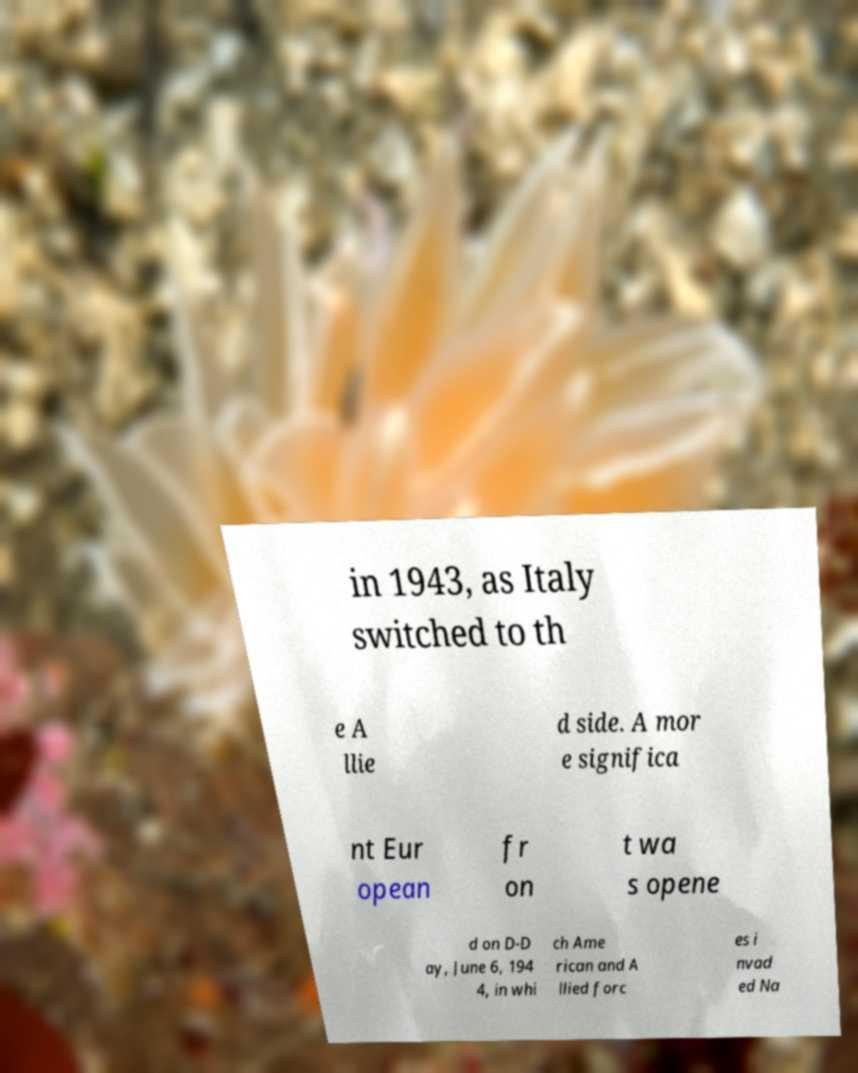Can you read and provide the text displayed in the image?This photo seems to have some interesting text. Can you extract and type it out for me? in 1943, as Italy switched to th e A llie d side. A mor e significa nt Eur opean fr on t wa s opene d on D-D ay, June 6, 194 4, in whi ch Ame rican and A llied forc es i nvad ed Na 